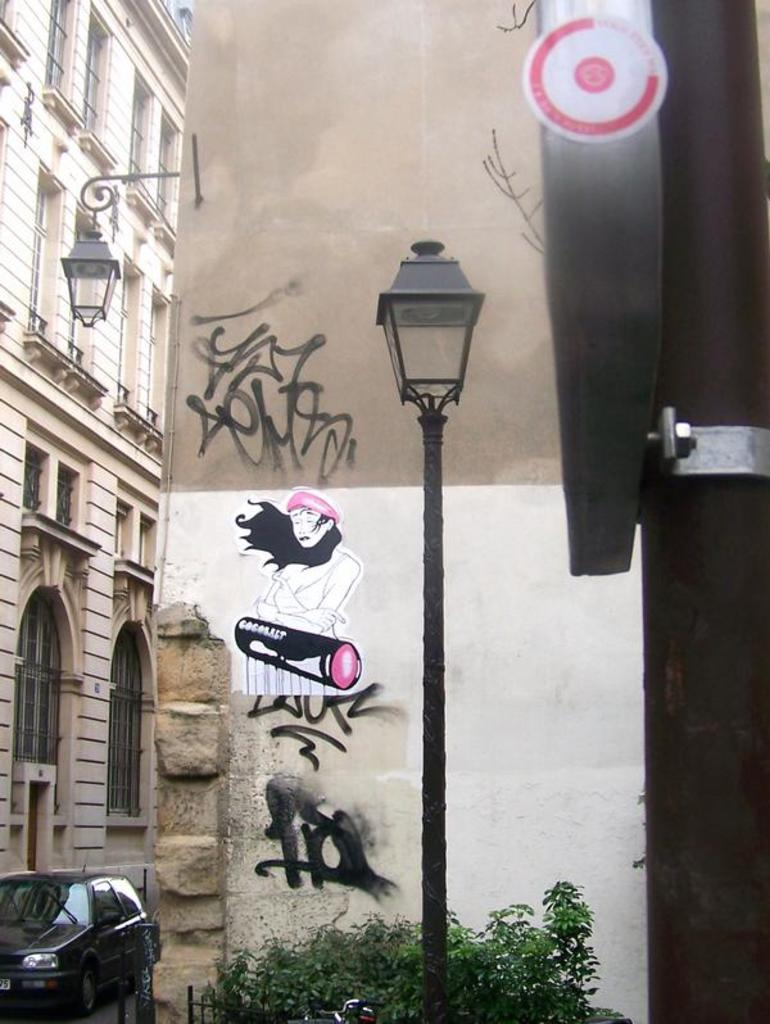What is located in the foreground of the picture? There is a pole, a street light, plants, and a wall in the foreground of the picture. What can be seen on the left side of the picture? There are buildings, another street light, and a car on the left side of the picture. What is the chance of winning the event depicted in the image? There is no event depicted in the image, so it is not possible to determine the chance of winning anything. How many wheels can be seen in the image? There is no wheel present in the image; the only vehicle mentioned is a car, but we cannot see its wheels in the image. 